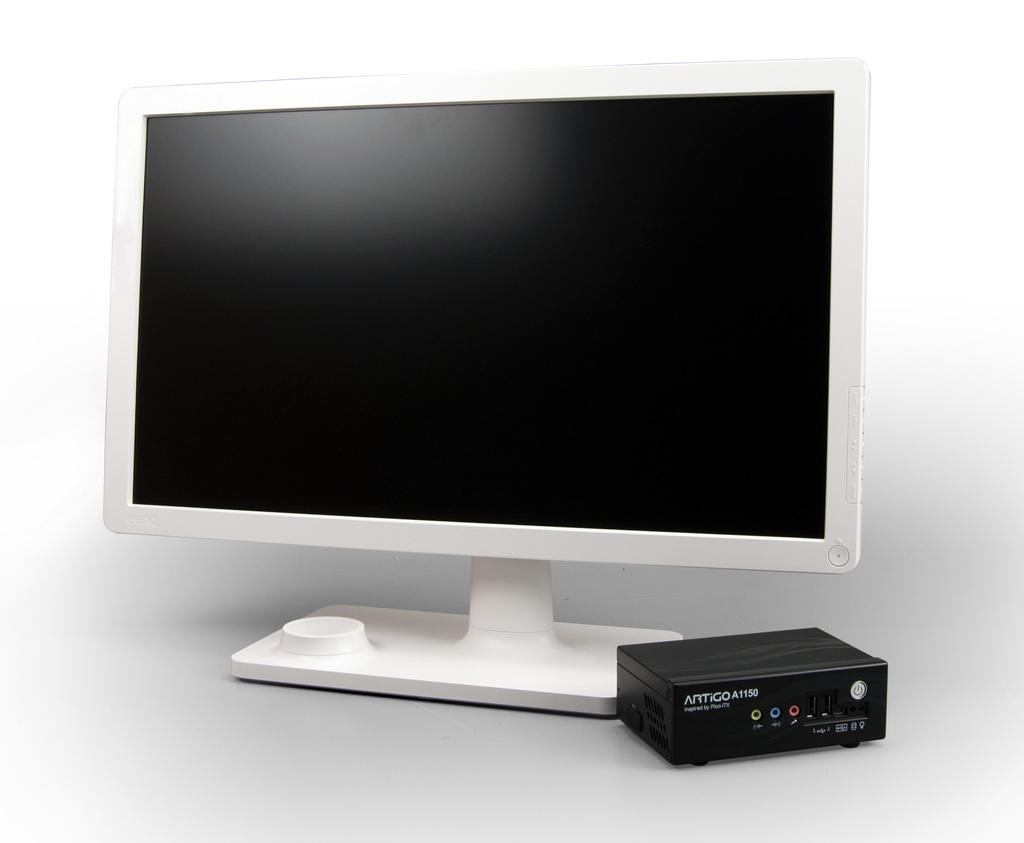<image>
Share a concise interpretation of the image provided. AN ALL IN ONE COMPUTER MONITOR AND BLACK BOX NETWORK 